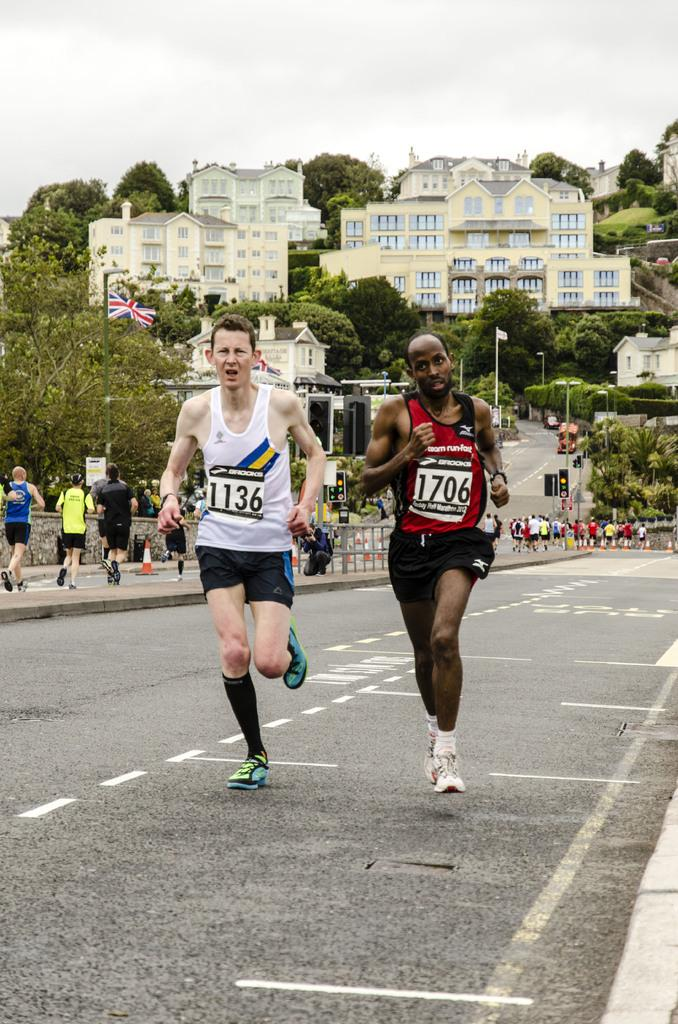What are the people in the image doing? The people in the image are running on the road and the footpath. What can be seen in the background of the image? There are trees and buildings visible in the image. What type of potato can be seen growing on the trees in the image? There are no potatoes visible in the image, and the trees are not growing potatoes. 